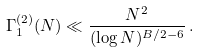Convert formula to latex. <formula><loc_0><loc_0><loc_500><loc_500>\Gamma _ { 1 } ^ { ( 2 ) } ( N ) \ll \frac { N ^ { 2 } } { ( \log N ) ^ { B / 2 - 6 } } \, .</formula> 